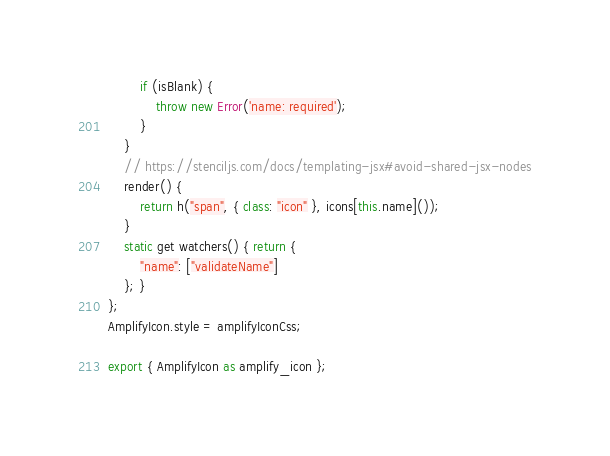<code> <loc_0><loc_0><loc_500><loc_500><_JavaScript_>        if (isBlank) {
            throw new Error('name: required');
        }
    }
    // https://stenciljs.com/docs/templating-jsx#avoid-shared-jsx-nodes
    render() {
        return h("span", { class: "icon" }, icons[this.name]());
    }
    static get watchers() { return {
        "name": ["validateName"]
    }; }
};
AmplifyIcon.style = amplifyIconCss;

export { AmplifyIcon as amplify_icon };
</code> 